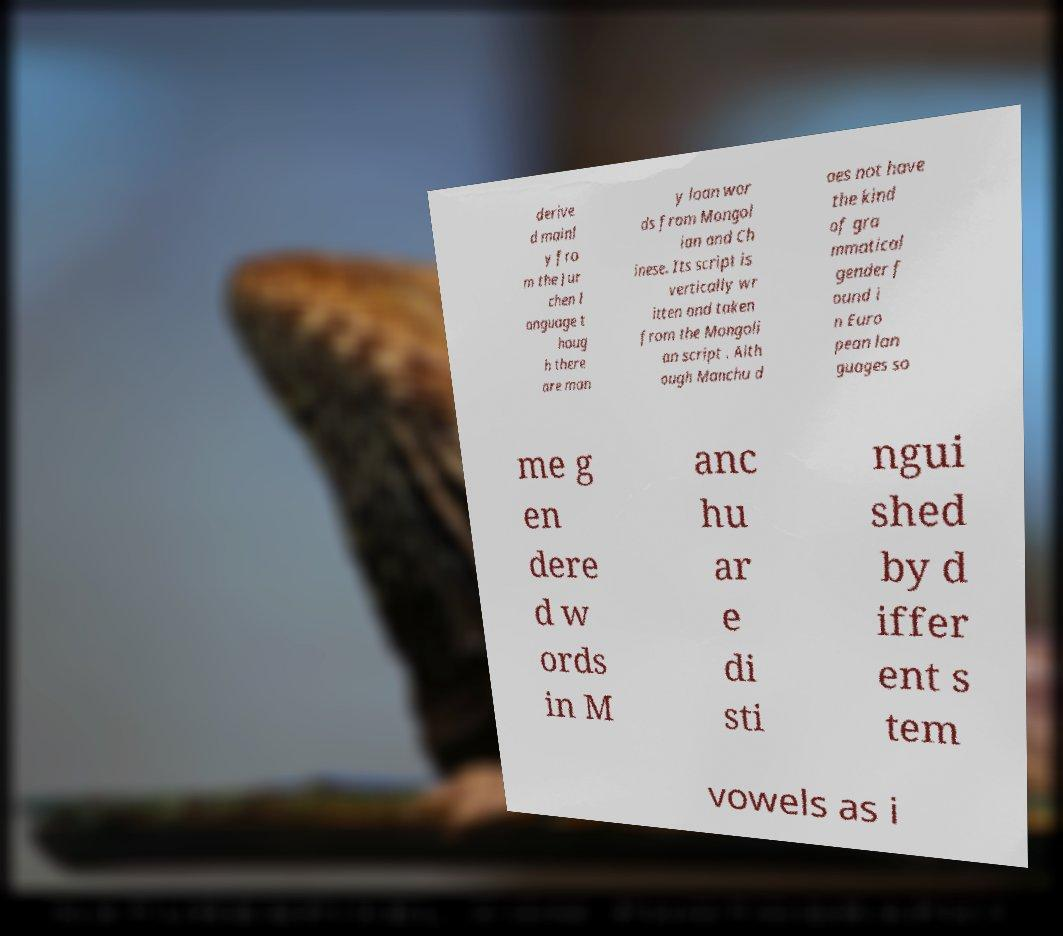Can you accurately transcribe the text from the provided image for me? derive d mainl y fro m the Jur chen l anguage t houg h there are man y loan wor ds from Mongol ian and Ch inese. Its script is vertically wr itten and taken from the Mongoli an script . Alth ough Manchu d oes not have the kind of gra mmatical gender f ound i n Euro pean lan guages so me g en dere d w ords in M anc hu ar e di sti ngui shed by d iffer ent s tem vowels as i 